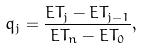Convert formula to latex. <formula><loc_0><loc_0><loc_500><loc_500>q _ { j } = \frac { E T _ { j } - E T _ { j - 1 } } { E T _ { n } - E T _ { 0 } } ,</formula> 